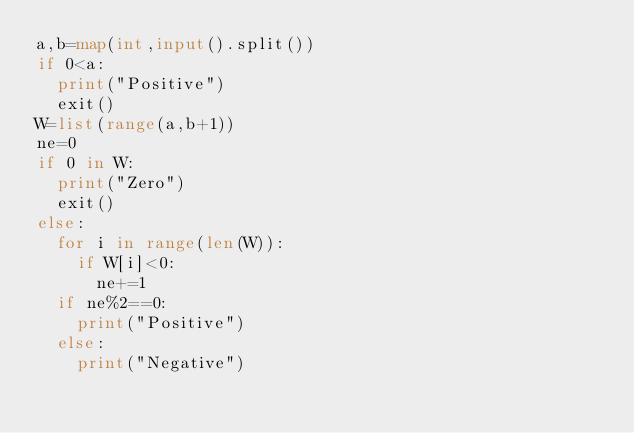<code> <loc_0><loc_0><loc_500><loc_500><_Python_>a,b=map(int,input().split())
if 0<a:
  print("Positive")
  exit()
W=list(range(a,b+1))
ne=0
if 0 in W:
  print("Zero")
  exit()
else:
  for i in range(len(W)):
    if W[i]<0:
      ne+=1
  if ne%2==0:
    print("Positive")
  else:
    print("Negative")

  
  
  
</code> 